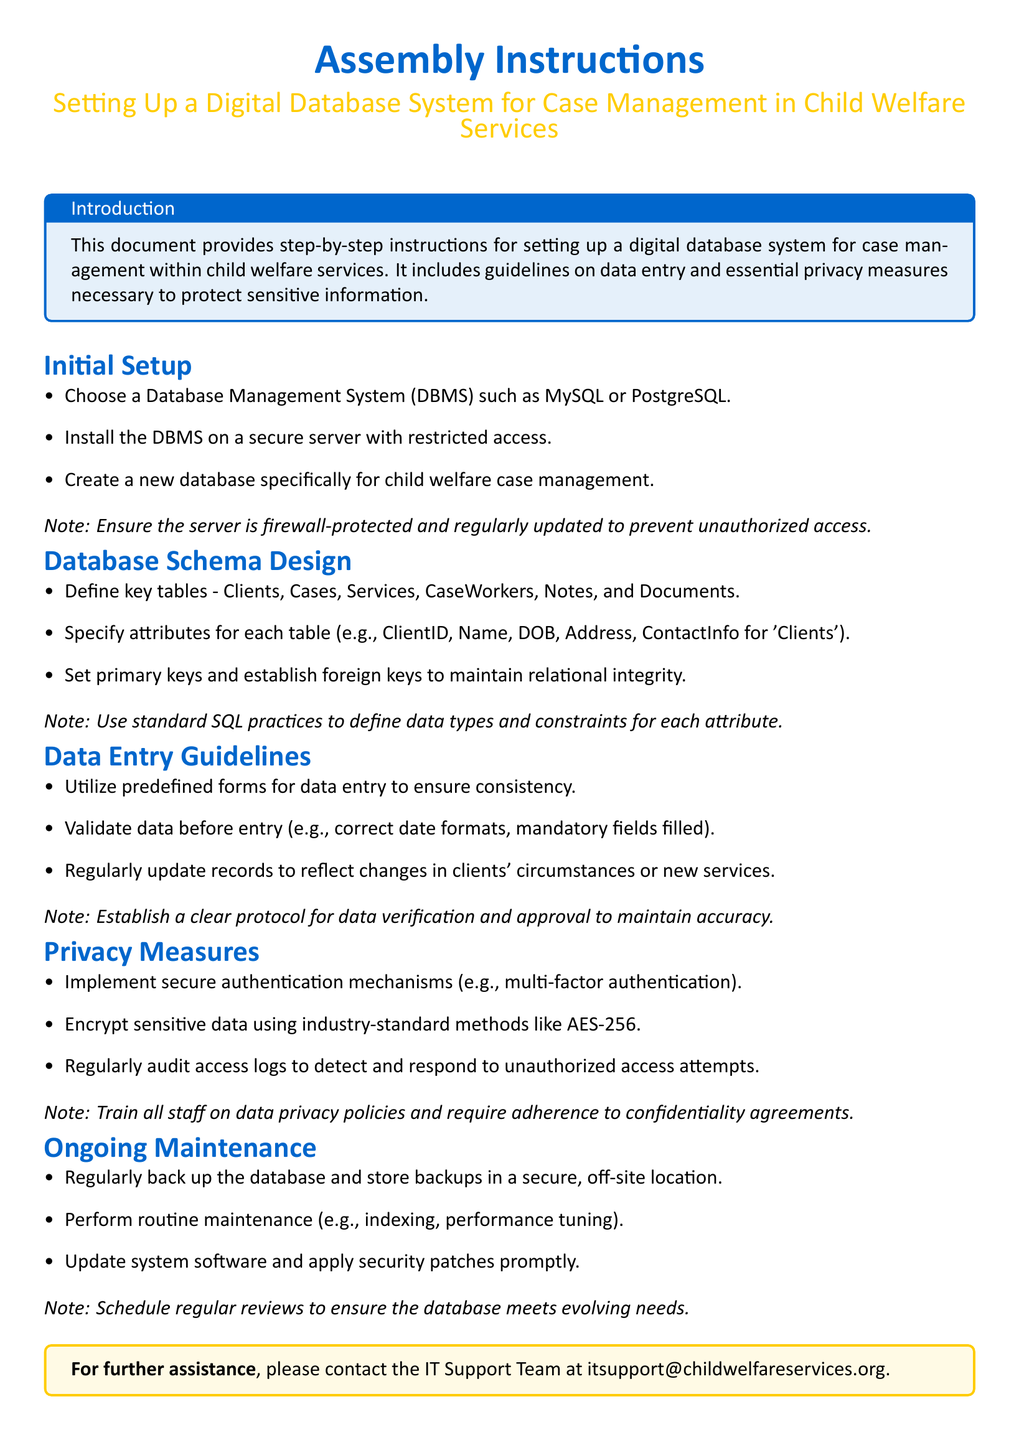What is the title of the document? The title is stated prominently at the beginning of the document, indicating the purpose of the assembly instructions.
Answer: Assembly Instructions Which Database Management Systems are suggested for initial setup? The document provides a list of recommended systems to choose from for setting up the database.
Answer: MySQL or PostgreSQL What is the first step in the Initial Setup section? The first step is clearly outlined as the initial action required to begin setting up the database system.
Answer: Choose a Database Management System What type of authentication is recommended for privacy measures? Recommended methods for securing data access are specified under the Privacy Measures section.
Answer: Multi-factor authentication What is the purpose of the Data Entry Guidelines section? This section explains the protocols to follow for entering data into the database effectively.
Answer: Ensure consistency How many key tables are defined in the Database Schema Design? The document lists the key tables necessary for organizing case management data.
Answer: Six What is emphasized in the ongoing maintenance section for database security? The document outlines important actions to take for the continual security and functionality of the database.
Answer: Regularly back up the database What encryption standard is recommended for sensitive data? The document specifies a particular industry-standard method for encrypting sensitive information.
Answer: AES-256 